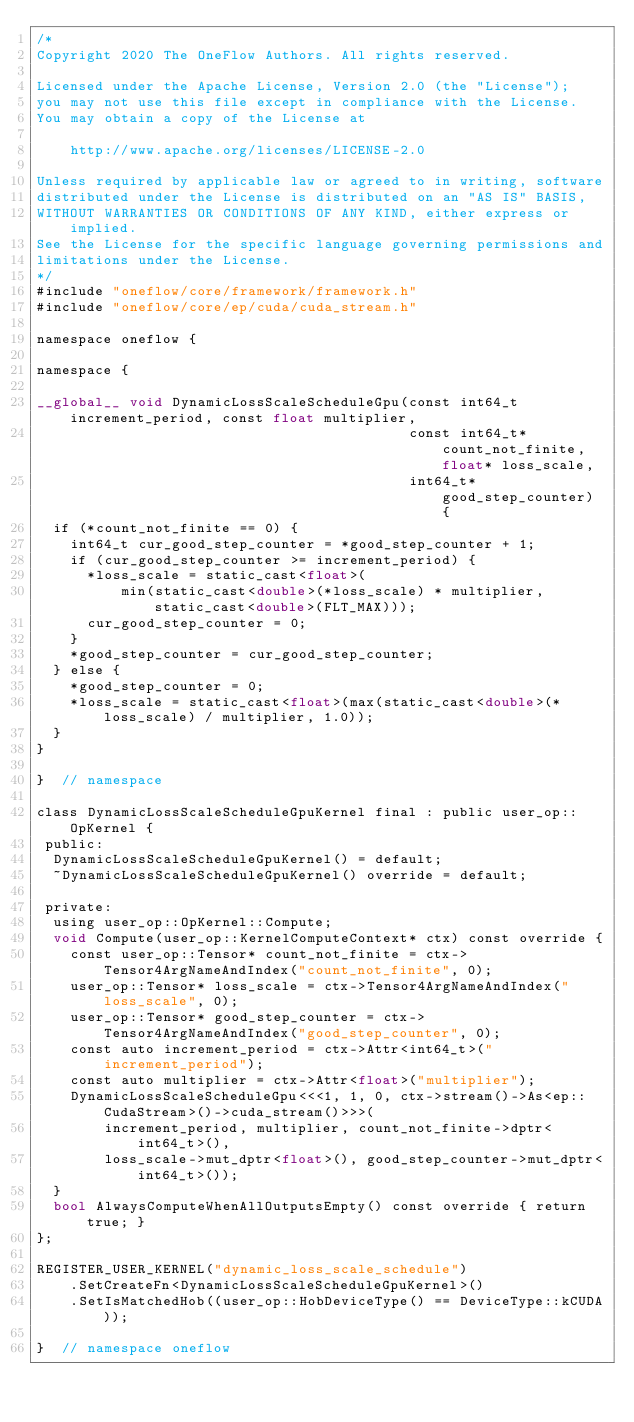Convert code to text. <code><loc_0><loc_0><loc_500><loc_500><_Cuda_>/*
Copyright 2020 The OneFlow Authors. All rights reserved.

Licensed under the Apache License, Version 2.0 (the "License");
you may not use this file except in compliance with the License.
You may obtain a copy of the License at

    http://www.apache.org/licenses/LICENSE-2.0

Unless required by applicable law or agreed to in writing, software
distributed under the License is distributed on an "AS IS" BASIS,
WITHOUT WARRANTIES OR CONDITIONS OF ANY KIND, either express or implied.
See the License for the specific language governing permissions and
limitations under the License.
*/
#include "oneflow/core/framework/framework.h"
#include "oneflow/core/ep/cuda/cuda_stream.h"

namespace oneflow {

namespace {

__global__ void DynamicLossScaleScheduleGpu(const int64_t increment_period, const float multiplier,
                                            const int64_t* count_not_finite, float* loss_scale,
                                            int64_t* good_step_counter) {
  if (*count_not_finite == 0) {
    int64_t cur_good_step_counter = *good_step_counter + 1;
    if (cur_good_step_counter >= increment_period) {
      *loss_scale = static_cast<float>(
          min(static_cast<double>(*loss_scale) * multiplier, static_cast<double>(FLT_MAX)));
      cur_good_step_counter = 0;
    }
    *good_step_counter = cur_good_step_counter;
  } else {
    *good_step_counter = 0;
    *loss_scale = static_cast<float>(max(static_cast<double>(*loss_scale) / multiplier, 1.0));
  }
}

}  // namespace

class DynamicLossScaleScheduleGpuKernel final : public user_op::OpKernel {
 public:
  DynamicLossScaleScheduleGpuKernel() = default;
  ~DynamicLossScaleScheduleGpuKernel() override = default;

 private:
  using user_op::OpKernel::Compute;
  void Compute(user_op::KernelComputeContext* ctx) const override {
    const user_op::Tensor* count_not_finite = ctx->Tensor4ArgNameAndIndex("count_not_finite", 0);
    user_op::Tensor* loss_scale = ctx->Tensor4ArgNameAndIndex("loss_scale", 0);
    user_op::Tensor* good_step_counter = ctx->Tensor4ArgNameAndIndex("good_step_counter", 0);
    const auto increment_period = ctx->Attr<int64_t>("increment_period");
    const auto multiplier = ctx->Attr<float>("multiplier");
    DynamicLossScaleScheduleGpu<<<1, 1, 0, ctx->stream()->As<ep::CudaStream>()->cuda_stream()>>>(
        increment_period, multiplier, count_not_finite->dptr<int64_t>(),
        loss_scale->mut_dptr<float>(), good_step_counter->mut_dptr<int64_t>());
  }
  bool AlwaysComputeWhenAllOutputsEmpty() const override { return true; }
};

REGISTER_USER_KERNEL("dynamic_loss_scale_schedule")
    .SetCreateFn<DynamicLossScaleScheduleGpuKernel>()
    .SetIsMatchedHob((user_op::HobDeviceType() == DeviceType::kCUDA));

}  // namespace oneflow
</code> 